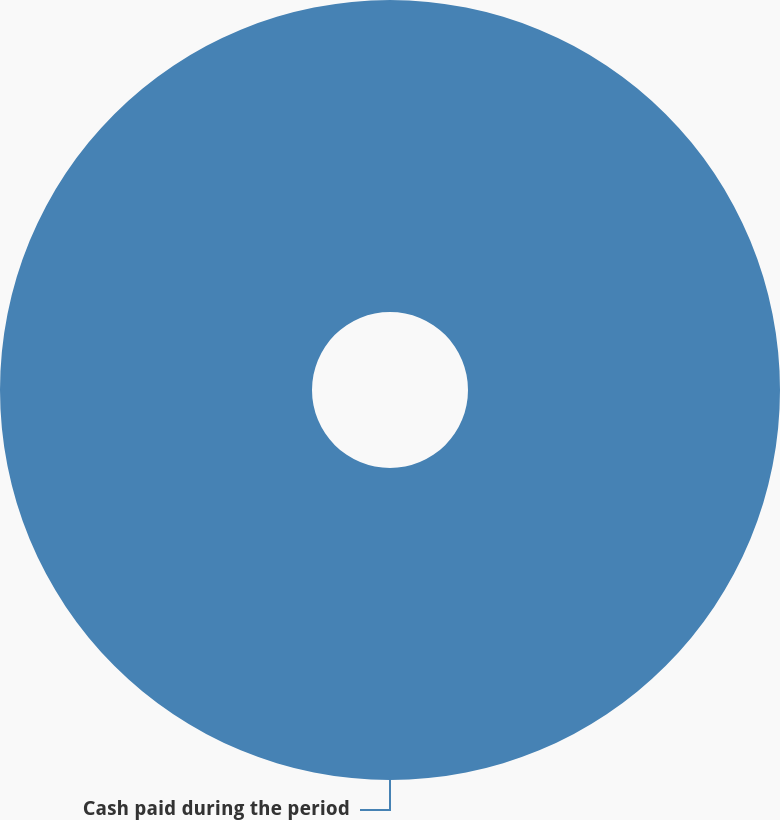Convert chart to OTSL. <chart><loc_0><loc_0><loc_500><loc_500><pie_chart><fcel>Cash paid during the period<nl><fcel>100.0%<nl></chart> 